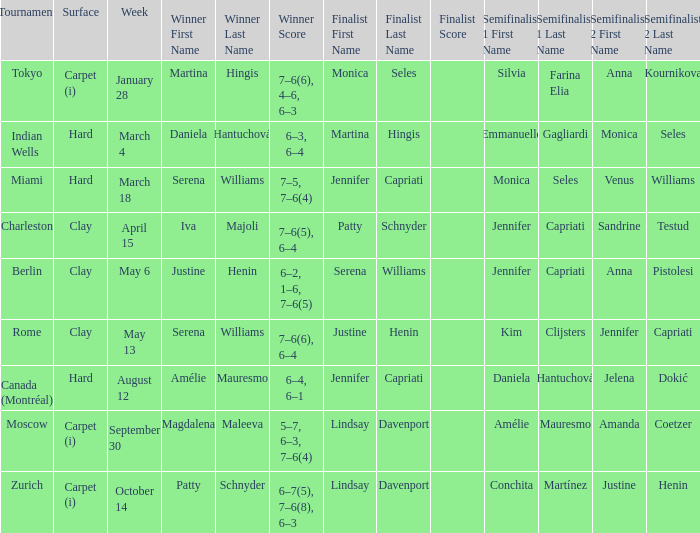Who claimed the title at indian wells? Daniela Hantuchová 6–3, 6–4. 